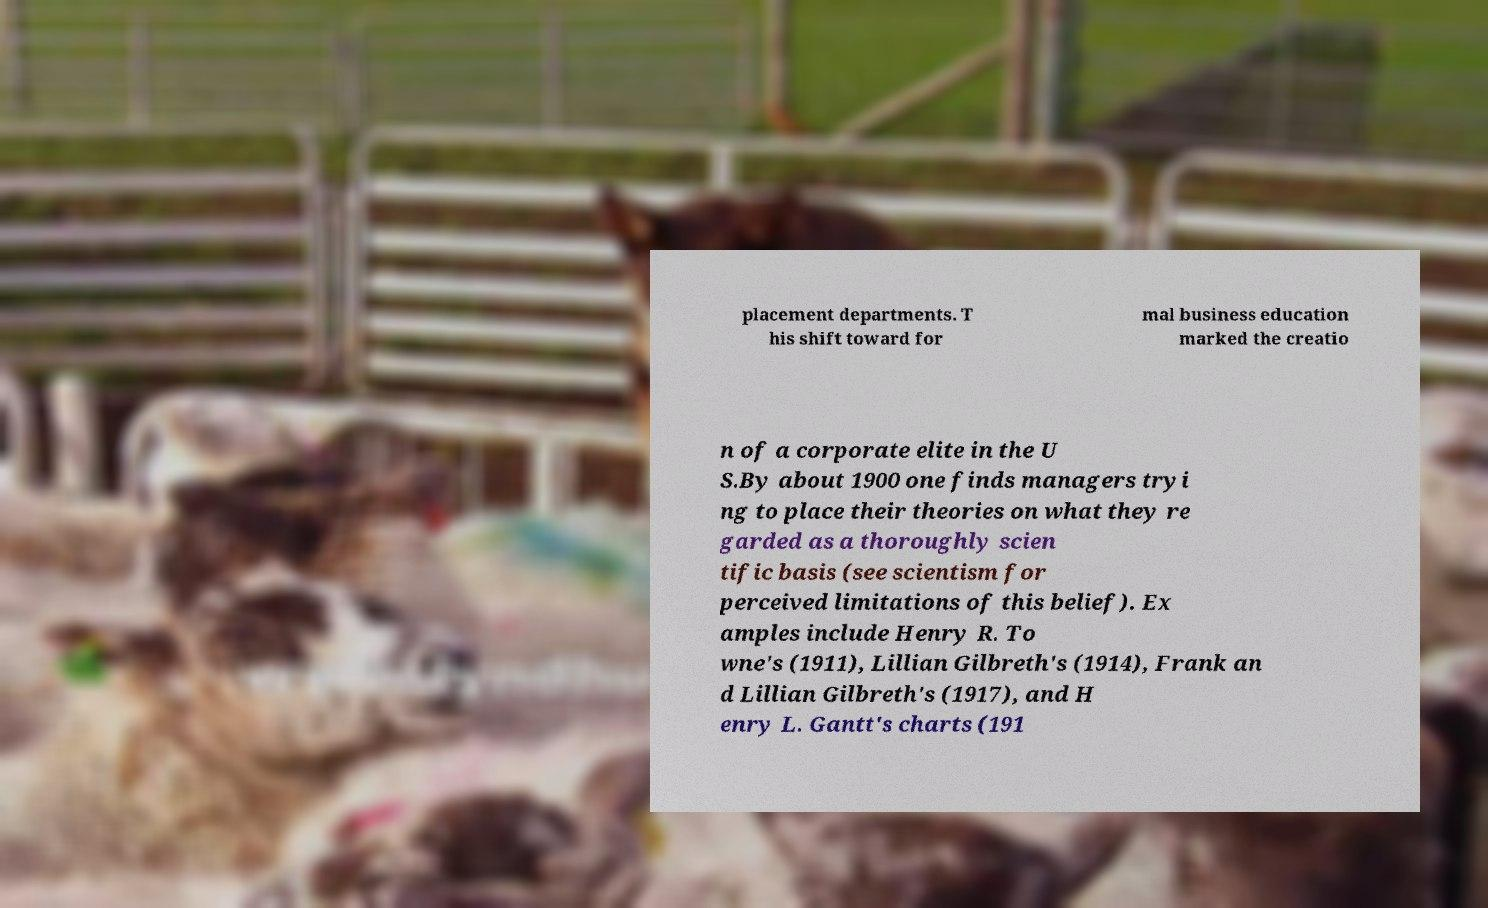Can you accurately transcribe the text from the provided image for me? placement departments. T his shift toward for mal business education marked the creatio n of a corporate elite in the U S.By about 1900 one finds managers tryi ng to place their theories on what they re garded as a thoroughly scien tific basis (see scientism for perceived limitations of this belief). Ex amples include Henry R. To wne's (1911), Lillian Gilbreth's (1914), Frank an d Lillian Gilbreth's (1917), and H enry L. Gantt's charts (191 